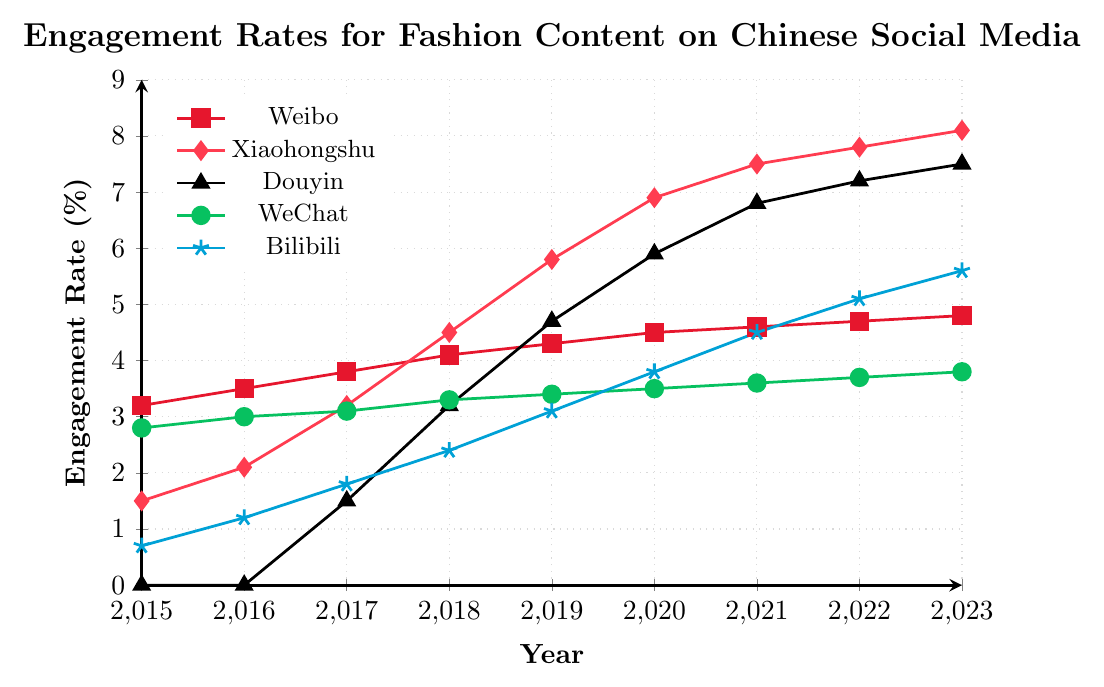What is the engagement rate for Xiaohongshu in 2023? Look for the data point corresponding to Xiaohongshu and the year 2023; the figure shows 8.1%.
Answer: 8.1% Which platform had the highest engagement rate in 2015? Examine the engagement rates for each platform in 2015. Weibo has the highest rate at 3.2%.
Answer: Weibo How much did the engagement rate of Bilibili increase from 2015 to 2023? Find the engagement rates of Bilibili for 2015 and 2023 and calculate the difference: 5.6% - 0.7% = 4.9%.
Answer: 4.9% Between which two consecutive years did Douyin see the greatest increase in engagement rate? Compare the year-to-year differences for Douyin. The increase between 2017 (1.5%) and 2018 (3.2%) is the greatest, with an increase of 1.7%.
Answer: 2017 and 2018 What is the average engagement rate for WeChat from 2015 to 2023? Sum the engagement rates for WeChat from 2015 to 2023 and divide by the number of years: (2.8 + 3.0 + 3.1 + 3.3 + 3.4 + 3.5 + 3.6 + 3.7 + 3.8) / 9 = 3.5%.
Answer: 3.5% Did any platform's engagement rate decrease between any two consecutive years? Review the engagement rate for each platform across consecutive years. None of the platforms show a decrease; all show either increases or remain the same.
Answer: No Which platform had the smallest change in engagement rate from 2015 to 2023? Calculate the change in engagement rate for each platform for the given period. Weibo's engagement rate increased from 3.2% to 4.8%, the smallest change being 1.6%.
Answer: Weibo Compare the engagement rate trends of Xiaohongshu and WeChat from 2015 to 2023; which trends are more steeply rising? Visually compare the slope of the lines representing Xiaohongshu and WeChat. Xiaohongshu’s line is steeper, indicating a more rapid increase in engagement rate.
Answer: Xiaohongshu What is the difference in engagement rates between Douyin and Bilibili in 2023? Look at the engagement rates for Douyin (7.5%) and Bilibili (5.6%) for 2023, then calculate the difference: 7.5% - 5.6% = 1.9%.
Answer: 1.9% Rank the platforms by their engagement rates in 2019. Review the engagement rates for each platform in 2019: Xiaohongshu (5.8%), Douyin (4.7%), Weibo (4.3%), WeChat (3.4%), and Bilibili (3.1%). Rank from highest to lowest: Xiaohongshu, Douyin, Weibo, WeChat, Bilibili.
Answer: Xiaohongshu, Douyin, Weibo, WeChat, Bilibili 